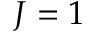Convert formula to latex. <formula><loc_0><loc_0><loc_500><loc_500>J = 1</formula> 